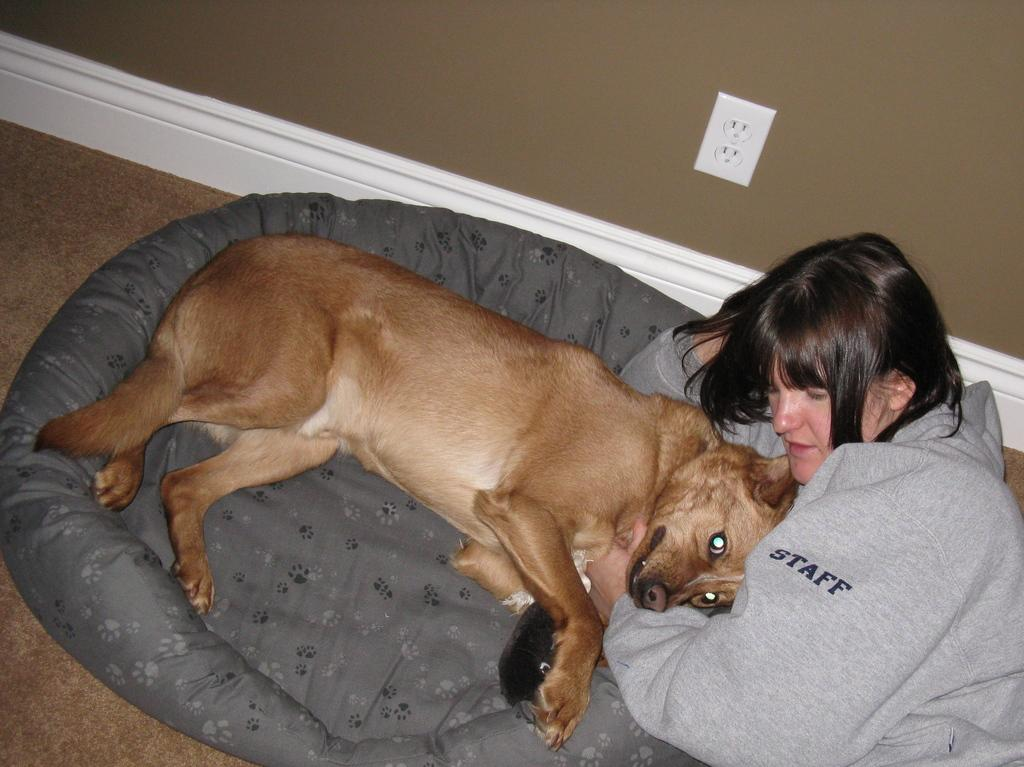Where was the image taken? The image was taken in a house. Who is present in the image? There is a woman in the image. What is the woman holding? The woman is holding a dog. Where is the dog located in the image? The dog is on a dog bed. What can be seen on the wall in the image? There is a wall visible in the image. How many kitties are playing with ants on the wall in the image? There are no kitties or ants present on the wall in the image. 